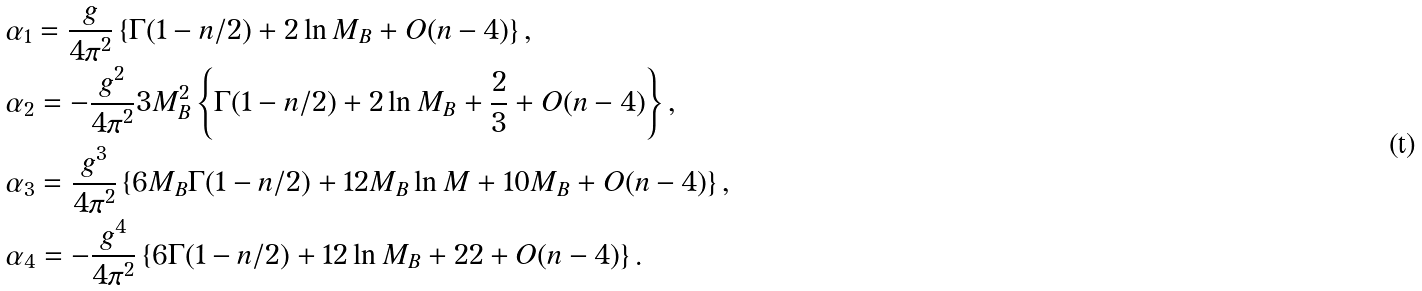Convert formula to latex. <formula><loc_0><loc_0><loc_500><loc_500>& \alpha _ { 1 } = \frac { g } { 4 \pi ^ { 2 } } \left \{ \Gamma ( 1 - n / 2 ) + 2 \ln M _ { B } + O ( n - 4 ) \right \} , \\ & \alpha _ { 2 } = - \frac { g ^ { 2 } } { 4 \pi ^ { 2 } } 3 M _ { B } ^ { 2 } \left \{ \Gamma ( 1 - n / 2 ) + 2 \ln M _ { B } + \frac { 2 } { 3 } + O ( n - 4 ) \right \} , \\ & \alpha _ { 3 } = \frac { g ^ { 3 } } { 4 \pi ^ { 2 } } \left \{ 6 M _ { B } \Gamma ( 1 - n / 2 ) + 1 2 M _ { B } \ln M + 1 0 M _ { B } + O ( n - 4 ) \right \} , \\ & \alpha _ { 4 } = - \frac { g ^ { 4 } } { 4 \pi ^ { 2 } } \left \{ 6 \Gamma ( 1 - n / 2 ) + 1 2 \ln M _ { B } + 2 2 + O ( n - 4 ) \right \} .</formula> 